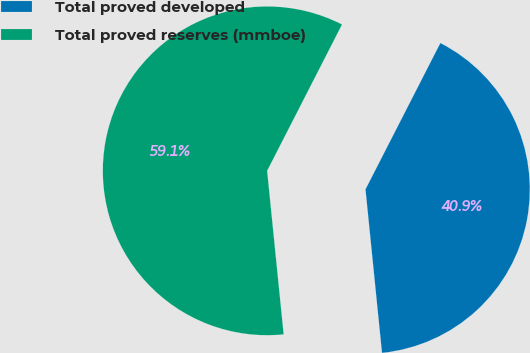<chart> <loc_0><loc_0><loc_500><loc_500><pie_chart><fcel>Total proved developed<fcel>Total proved reserves (mmboe)<nl><fcel>40.87%<fcel>59.13%<nl></chart> 